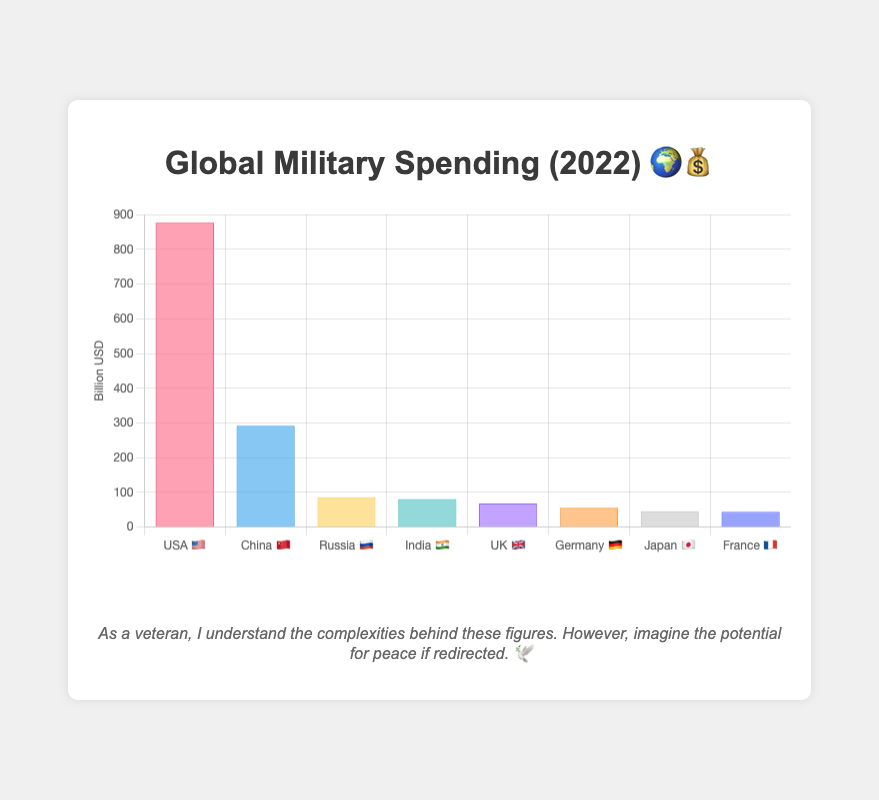Which country has the highest military spending? The height of the bar for the USA 🇺🇸 is the tallest on the chart, indicating that it has the highest military spending.
Answer: USA 🇺🇸 What is the total military spending of Russia 🇷🇺 and India 🇮🇳 combined? Add Russia's spending (86 Billion USD) and India's spending (81 Billion USD) together: 86 + 81 = 167 Billion USD.
Answer: 167 Billion USD Which country spends more on the military, Germany 🇩🇪 or France 🇫🇷? Compare the heights of the bars for Germany 🇩🇪 (56 Billion USD) and France 🇫🇷 (44 Billion USD). Germany spends more.
Answer: Germany 🇩🇪 How much more does the USA 🇺🇸 spend on military compared to China 🇨🇳? Subtract China's spending (292 Billion USD) from the USA's spending (877 Billion USD): 877 - 292 = 585 Billion USD.
Answer: 585 Billion USD Which country has the lowest military spending on the chart? The bar for France 🇫🇷 is the shortest among all the bars in the chart.
Answer: France 🇫🇷 What is the average military spending of the countries listed in the chart? Add the spending of all countries and divide by the number of countries: (877 + 292 + 86 + 81 + 68 + 56 + 46 + 44) / 8 = 1937 / 8 = 242.125 Billion USD.
Answer: 242.125 Billion USD Order the countries by their military spending from highest to lowest. Observe the heights of the bars: USA 🇺🇸, China 🇨🇳, Russia 🇷🇺, India 🇮🇳, UK 🇬🇧, Germany 🇩🇪, Japan 🇯🇵, France 🇫🇷.
Answer: USA 🇺🇸, China 🇨🇳, Russia 🇷🇺, India 🇮🇳, UK 🇬🇧, Germany 🇩🇪, Japan 🇯🇵, France 🇫🇷 What is the median military spending of the countries listed? Order the spending values and find the middle value: [44, 46, 56, 68, 81, 86, 292, 877]. The middle values are 68 and 81. The median is (68 + 81) / 2 = 74.5 Billion USD.
Answer: 74.5 Billion USD How many times more does the USA 🇺🇸 spend compared to Japan 🇯🇵? Divide the USA's spending by Japan's spending: 877 / 46 ≈ 19.07.
Answer: 19.07 